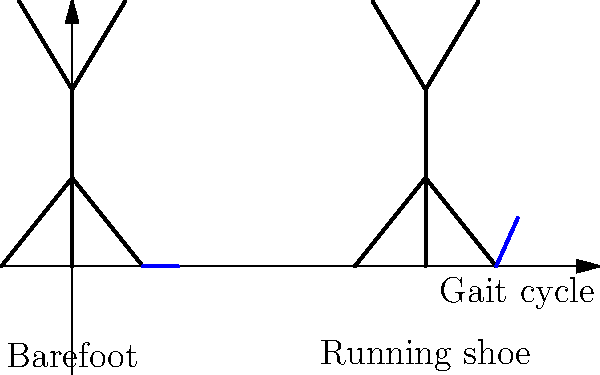Based on the stick figure diagrams, which shows a greater ankle dorsiflexion angle during the initial contact phase of gait: a child wearing running shoes or a barefoot child? To answer this question, we need to analyze the ankle angle in both stick figures:

1. Barefoot child (left figure):
   - The foot is relatively flat, almost parallel to the ground.
   - The ankle angle is close to neutral (0 degrees).

2. Child with running shoe (right figure):
   - The foot is angled upwards at the heel.
   - There is a noticeable angle between the leg and the foot.

3. Ankle dorsiflexion is the upward movement of the foot towards the shin.

4. In the running shoe diagram, we can see that the foot is more angled upwards, indicating a greater degree of dorsiflexion.

5. This increased dorsiflexion in the running shoe condition is due to:
   - The elevated heel in most running shoes.
   - The stiffer sole of the shoe, which can alter natural foot mechanics.

6. The barefoot condition allows for a more natural foot placement, typically with a flatter initial contact.

Therefore, based on the diagrams, the child wearing running shoes demonstrates a greater ankle dorsiflexion angle during the initial contact phase of gait compared to the barefoot child.
Answer: Child wearing running shoes 